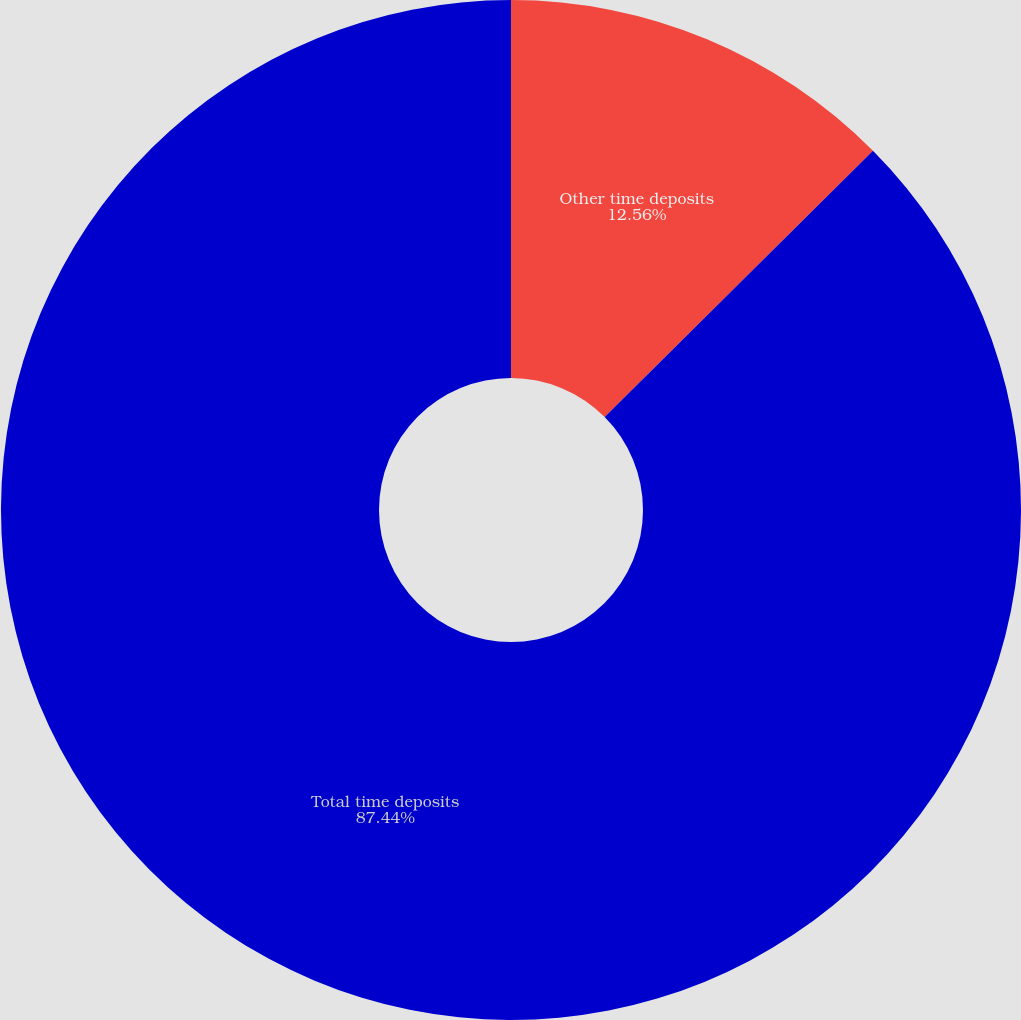Convert chart to OTSL. <chart><loc_0><loc_0><loc_500><loc_500><pie_chart><fcel>Other time deposits<fcel>Total time deposits<nl><fcel>12.56%<fcel>87.44%<nl></chart> 